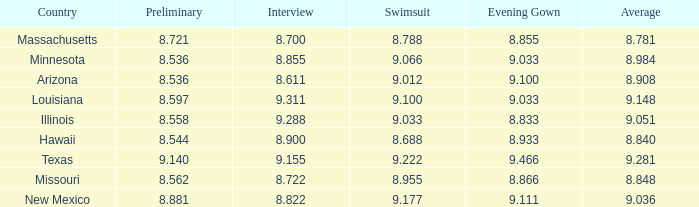What was the swimsuit score for the country with the average score of 8.848? 8.955. 